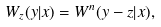Convert formula to latex. <formula><loc_0><loc_0><loc_500><loc_500>W _ { z } ( y | x ) = W ^ { n } ( y - z | x ) ,</formula> 